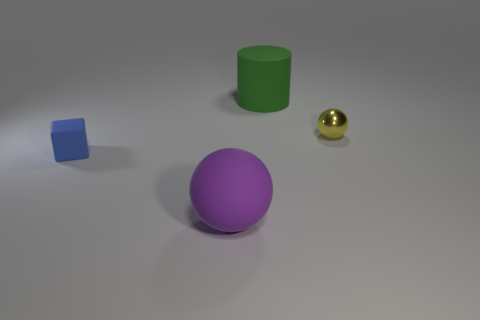Add 3 blue rubber blocks. How many objects exist? 7 Subtract all cubes. How many objects are left? 3 Subtract all big red rubber cubes. Subtract all big matte balls. How many objects are left? 3 Add 1 yellow objects. How many yellow objects are left? 2 Add 4 metal things. How many metal things exist? 5 Subtract 0 green balls. How many objects are left? 4 Subtract all purple cubes. Subtract all gray spheres. How many cubes are left? 1 